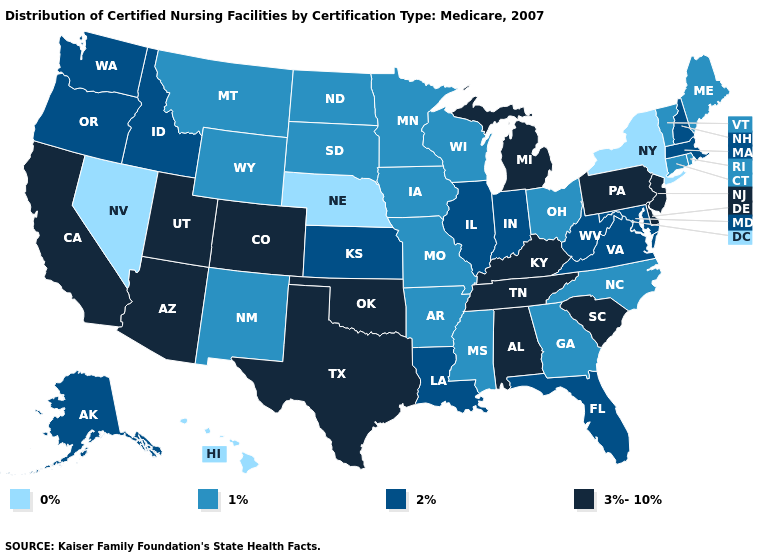What is the value of Idaho?
Short answer required. 2%. Does Pennsylvania have the highest value in the Northeast?
Keep it brief. Yes. How many symbols are there in the legend?
Give a very brief answer. 4. Does Washington have a higher value than Rhode Island?
Answer briefly. Yes. Among the states that border New Mexico , which have the highest value?
Write a very short answer. Arizona, Colorado, Oklahoma, Texas, Utah. Among the states that border California , which have the highest value?
Quick response, please. Arizona. Name the states that have a value in the range 3%-10%?
Answer briefly. Alabama, Arizona, California, Colorado, Delaware, Kentucky, Michigan, New Jersey, Oklahoma, Pennsylvania, South Carolina, Tennessee, Texas, Utah. Name the states that have a value in the range 2%?
Give a very brief answer. Alaska, Florida, Idaho, Illinois, Indiana, Kansas, Louisiana, Maryland, Massachusetts, New Hampshire, Oregon, Virginia, Washington, West Virginia. What is the lowest value in the Northeast?
Quick response, please. 0%. Does Pennsylvania have the highest value in the Northeast?
Be succinct. Yes. What is the value of Mississippi?
Keep it brief. 1%. What is the value of Idaho?
Be succinct. 2%. What is the value of Arkansas?
Answer briefly. 1%. Does Alabama have a lower value than Oregon?
Concise answer only. No. What is the lowest value in states that border Kansas?
Give a very brief answer. 0%. 